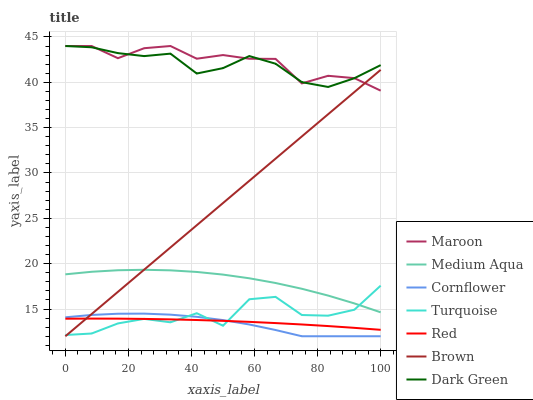Does Cornflower have the minimum area under the curve?
Answer yes or no. Yes. Does Maroon have the maximum area under the curve?
Answer yes or no. Yes. Does Turquoise have the minimum area under the curve?
Answer yes or no. No. Does Turquoise have the maximum area under the curve?
Answer yes or no. No. Is Brown the smoothest?
Answer yes or no. Yes. Is Turquoise the roughest?
Answer yes or no. Yes. Is Turquoise the smoothest?
Answer yes or no. No. Is Brown the roughest?
Answer yes or no. No. Does Cornflower have the lowest value?
Answer yes or no. Yes. Does Turquoise have the lowest value?
Answer yes or no. No. Does Dark Green have the highest value?
Answer yes or no. Yes. Does Turquoise have the highest value?
Answer yes or no. No. Is Medium Aqua less than Maroon?
Answer yes or no. Yes. Is Dark Green greater than Brown?
Answer yes or no. Yes. Does Red intersect Brown?
Answer yes or no. Yes. Is Red less than Brown?
Answer yes or no. No. Is Red greater than Brown?
Answer yes or no. No. Does Medium Aqua intersect Maroon?
Answer yes or no. No. 